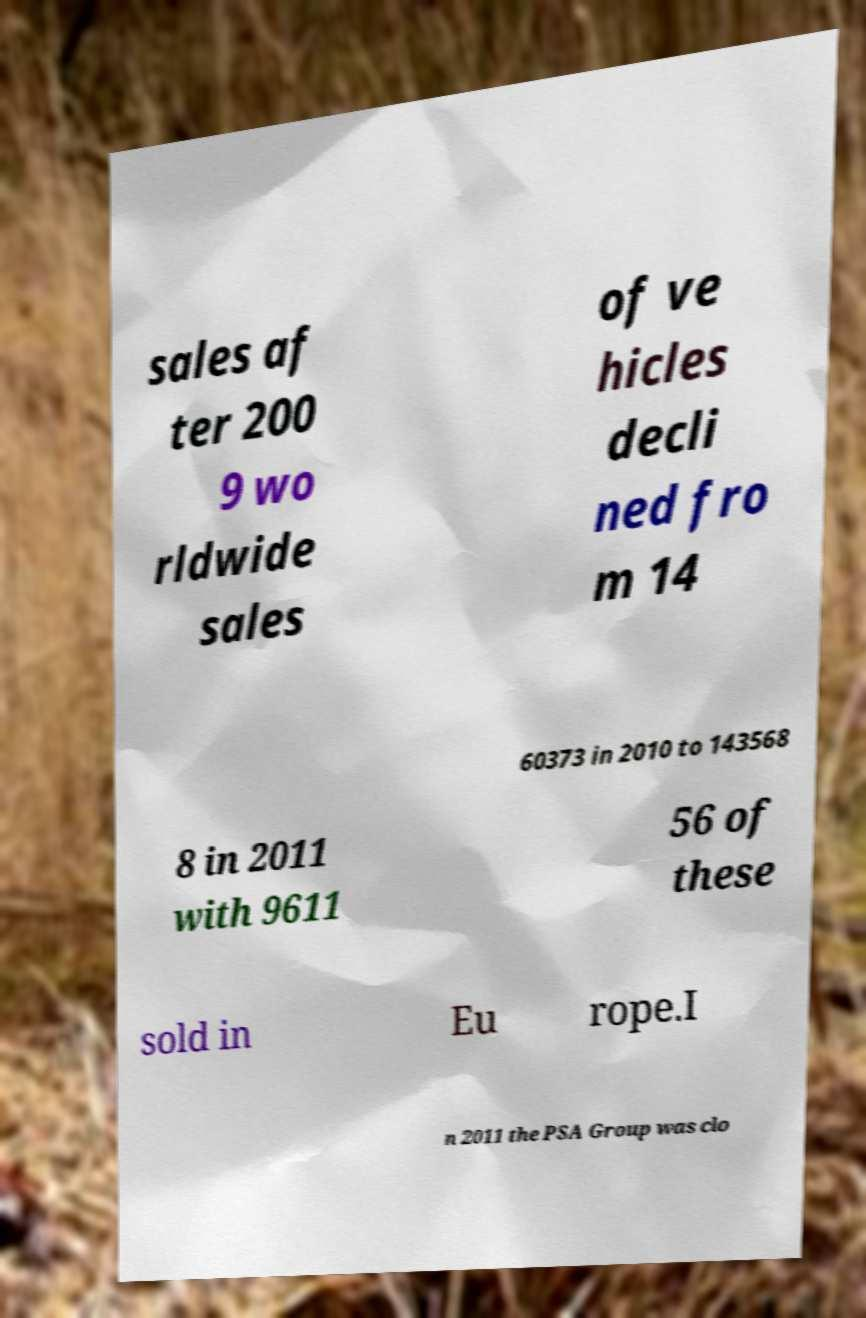Could you assist in decoding the text presented in this image and type it out clearly? sales af ter 200 9 wo rldwide sales of ve hicles decli ned fro m 14 60373 in 2010 to 143568 8 in 2011 with 9611 56 of these sold in Eu rope.I n 2011 the PSA Group was clo 